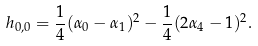<formula> <loc_0><loc_0><loc_500><loc_500>h _ { 0 , 0 } = \frac { 1 } { 4 } ( \alpha _ { 0 } - \alpha _ { 1 } ) ^ { 2 } - \frac { 1 } { 4 } ( 2 \alpha _ { 4 } - 1 ) ^ { 2 } .</formula> 